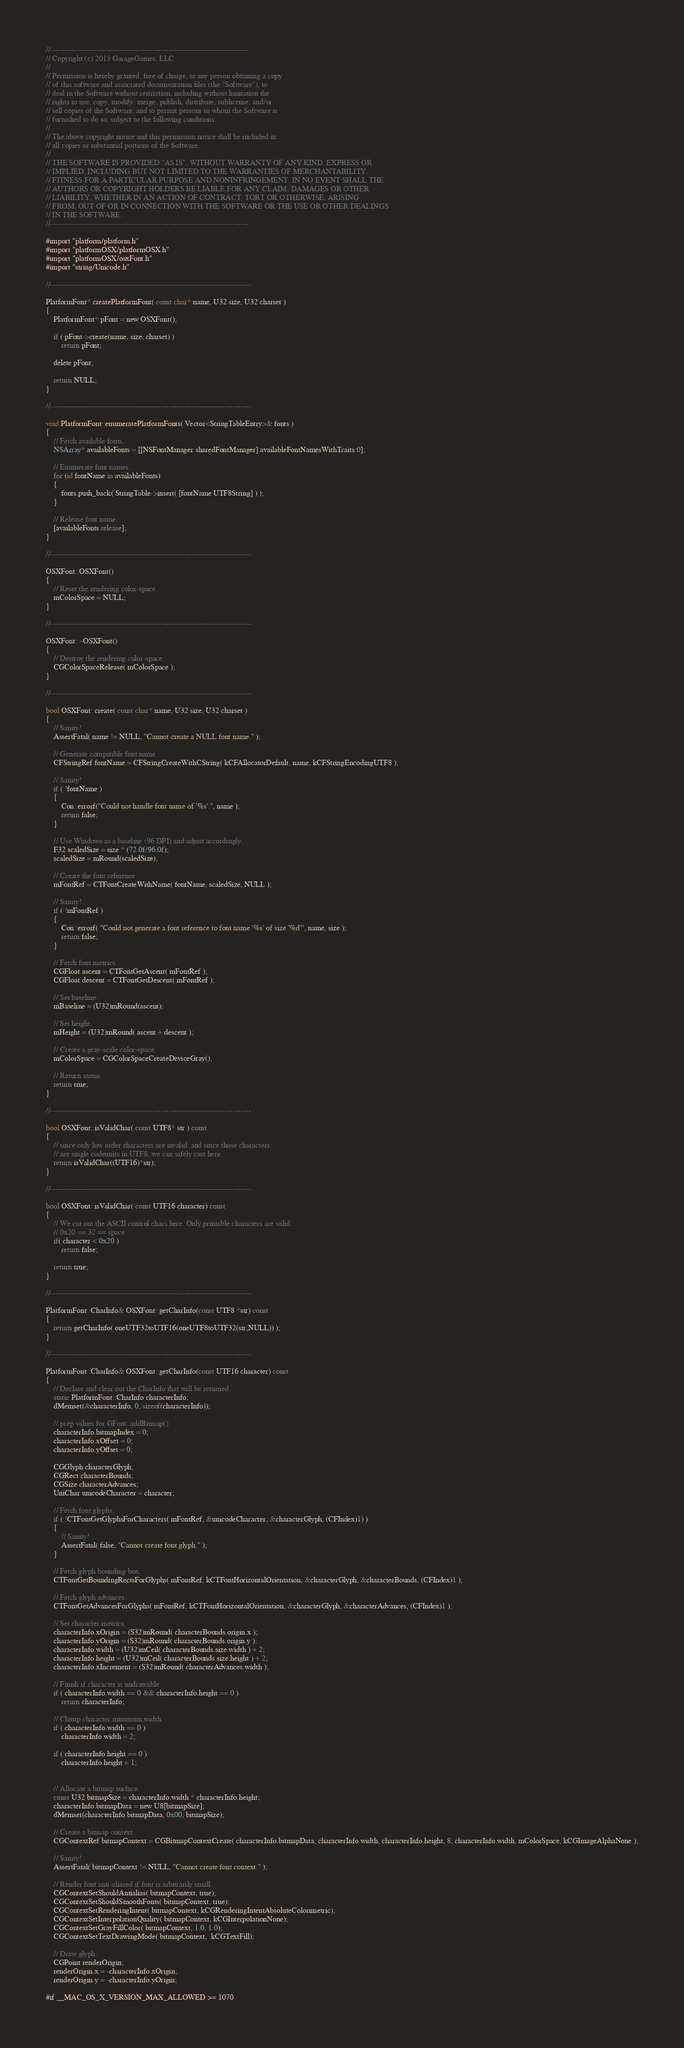Convert code to text. <code><loc_0><loc_0><loc_500><loc_500><_ObjectiveC_>//-----------------------------------------------------------------------------
// Copyright (c) 2013 GarageGames, LLC
//
// Permission is hereby granted, free of charge, to any person obtaining a copy
// of this software and associated documentation files (the "Software"), to
// deal in the Software without restriction, including without limitation the
// rights to use, copy, modify, merge, publish, distribute, sublicense, and/or
// sell copies of the Software, and to permit persons to whom the Software is
// furnished to do so, subject to the following conditions:
//
// The above copyright notice and this permission notice shall be included in
// all copies or substantial portions of the Software.
//
// THE SOFTWARE IS PROVIDED "AS IS", WITHOUT WARRANTY OF ANY KIND, EXPRESS OR
// IMPLIED, INCLUDING BUT NOT LIMITED TO THE WARRANTIES OF MERCHANTABILITY,
// FITNESS FOR A PARTICULAR PURPOSE AND NONINFRINGEMENT. IN NO EVENT SHALL THE
// AUTHORS OR COPYRIGHT HOLDERS BE LIABLE FOR ANY CLAIM, DAMAGES OR OTHER
// LIABILITY, WHETHER IN AN ACTION OF CONTRACT, TORT OR OTHERWISE, ARISING
// FROM, OUT OF OR IN CONNECTION WITH THE SOFTWARE OR THE USE OR OTHER DEALINGS
// IN THE SOFTWARE.
//-----------------------------------------------------------------------------
 
#import "platform/platform.h"
#import "platformOSX/platformOSX.h"
#import "platformOSX/osxFont.h"
#import "string/Unicode.h"

//------------------------------------------------------------------------------

PlatformFont* createPlatformFont( const char* name, U32 size, U32 charset )
{
    PlatformFont* pFont = new OSXFont();
    
    if ( pFont->create(name, size, charset) )
        return pFont;
    
    delete pFont;
    
    return NULL;
}

//------------------------------------------------------------------------------

void PlatformFont::enumeratePlatformFonts( Vector<StringTableEntry>& fonts )
{
    // Fetch available fonts.
    NSArray* availableFonts = [[NSFontManager sharedFontManager] availableFontNamesWithTraits:0];

    // Enumerate font names.
    for (id fontName in availableFonts)
    {
        fonts.push_back( StringTable->insert( [fontName UTF8String] ) );
    }

    // Release font name.
    [availableFonts release];
}

//------------------------------------------------------------------------------

OSXFont::OSXFont()
{
    // Reset the rendering color-space.
    mColorSpace = NULL;
}

//------------------------------------------------------------------------------

OSXFont::~OSXFont()
{
    // Destroy the rendering color-space.
    CGColorSpaceRelease( mColorSpace );
}

//------------------------------------------------------------------------------

bool OSXFont::create( const char* name, U32 size, U32 charset )
{
    // Sanity!
    AssertFatal( name != NULL, "Cannot create a NULL font name." );

    // Generate compatible font name.
    CFStringRef fontName = CFStringCreateWithCString( kCFAllocatorDefault, name, kCFStringEncodingUTF8 );

    // Sanity!
    if ( !fontName )
    {
        Con::errorf("Could not handle font name of '%s'.", name );
        return false;
    }

    // Use Windows as a baseline (96 DPI) and adjust accordingly.
    F32 scaledSize = size * (72.0f/96.0f);
    scaledSize = mRound(scaledSize);

    // Create the font reference.
    mFontRef = CTFontCreateWithName( fontName, scaledSize, NULL );

    // Sanity!
    if ( !mFontRef )
    {
        Con::errorf( "Could not generate a font reference to font name '%s' of size '%d'", name, size );
        return false;
    }

    // Fetch font metrics.
    CGFloat ascent = CTFontGetAscent( mFontRef );
    CGFloat descent = CTFontGetDescent( mFontRef );

    // Set baseline.
    mBaseline = (U32)mRound(ascent);

    // Set height.
    mHeight = (U32)mRound( ascent + descent );

    // Create a gray-scale color-space.
    mColorSpace = CGColorSpaceCreateDeviceGray();

    // Return status.
    return true;
}

//------------------------------------------------------------------------------

bool OSXFont::isValidChar( const UTF8* str ) const
{
    // since only low order characters are invalid, and since those characters
    // are single codeunits in UTF8, we can safely cast here.
    return isValidChar((UTF16)*str);
}

//------------------------------------------------------------------------------

bool OSXFont::isValidChar( const UTF16 character) const
{
    // We cut out the ASCII control chars here. Only printable characters are valid.
    // 0x20 == 32 == space
    if( character < 0x20 )
        return false;
    
    return true;
}

//------------------------------------------------------------------------------

PlatformFont::CharInfo& OSXFont::getCharInfo(const UTF8 *str) const
{
    return getCharInfo( oneUTF32toUTF16(oneUTF8toUTF32(str,NULL)) );
}

//------------------------------------------------------------------------------

PlatformFont::CharInfo& OSXFont::getCharInfo(const UTF16 character) const
{
    // Declare and clear out the CharInfo that will be returned.
    static PlatformFont::CharInfo characterInfo;
    dMemset(&characterInfo, 0, sizeof(characterInfo));
    
    // prep values for GFont::addBitmap()
    characterInfo.bitmapIndex = 0;
    characterInfo.xOffset = 0;
    characterInfo.yOffset = 0;

    CGGlyph characterGlyph;
    CGRect characterBounds;
    CGSize characterAdvances;
    UniChar unicodeCharacter = character;

    // Fetch font glyphs.
    if ( !CTFontGetGlyphsForCharacters( mFontRef, &unicodeCharacter, &characterGlyph, (CFIndex)1) )
    {
        // Sanity!
        AssertFatal( false, "Cannot create font glyph." );
    }

    // Fetch glyph bounding box.
    CTFontGetBoundingRectsForGlyphs( mFontRef, kCTFontHorizontalOrientation, &characterGlyph, &characterBounds, (CFIndex)1 );

    // Fetch glyph advances.
    CTFontGetAdvancesForGlyphs( mFontRef, kCTFontHorizontalOrientation, &characterGlyph, &characterAdvances, (CFIndex)1 );

    // Set character metrics,
    characterInfo.xOrigin = (S32)mRound( characterBounds.origin.x );
    characterInfo.yOrigin = (S32)mRound( characterBounds.origin.y );
    characterInfo.width = (U32)mCeil( characterBounds.size.width ) + 2;
    characterInfo.height = (U32)mCeil( characterBounds.size.height ) + 2;
    characterInfo.xIncrement = (S32)mRound( characterAdvances.width );

    // Finish if character is undrawable.
    if ( characterInfo.width == 0 && characterInfo.height == 0 )
        return characterInfo;

    // Clamp character minimum width.
    if ( characterInfo.width == 0 )
        characterInfo.width = 2;

    if ( characterInfo.height == 0 )
        characterInfo.height = 1;


    // Allocate a bitmap surface.
    const U32 bitmapSize = characterInfo.width * characterInfo.height;
    characterInfo.bitmapData = new U8[bitmapSize];
    dMemset(characterInfo.bitmapData, 0x00, bitmapSize);

    // Create a bitmap context.
    CGContextRef bitmapContext = CGBitmapContextCreate( characterInfo.bitmapData, characterInfo.width, characterInfo.height, 8, characterInfo.width, mColorSpace, kCGImageAlphaNone );

    // Sanity!
    AssertFatal( bitmapContext != NULL, "Cannot create font context." );

    // Render font anti-aliased if font is arbitrarily small.
    CGContextSetShouldAntialias( bitmapContext, true);
    CGContextSetShouldSmoothFonts( bitmapContext, true);
    CGContextSetRenderingIntent( bitmapContext, kCGRenderingIntentAbsoluteColorimetric);
    CGContextSetInterpolationQuality( bitmapContext, kCGInterpolationNone);
    CGContextSetGrayFillColor( bitmapContext, 1.0, 1.0);
    CGContextSetTextDrawingMode( bitmapContext,  kCGTextFill);

    // Draw glyph. 
    CGPoint renderOrigin;
    renderOrigin.x = -characterInfo.xOrigin;
    renderOrigin.y = -characterInfo.yOrigin;
    
#if __MAC_OS_X_VERSION_MAX_ALLOWED >= 1070</code> 